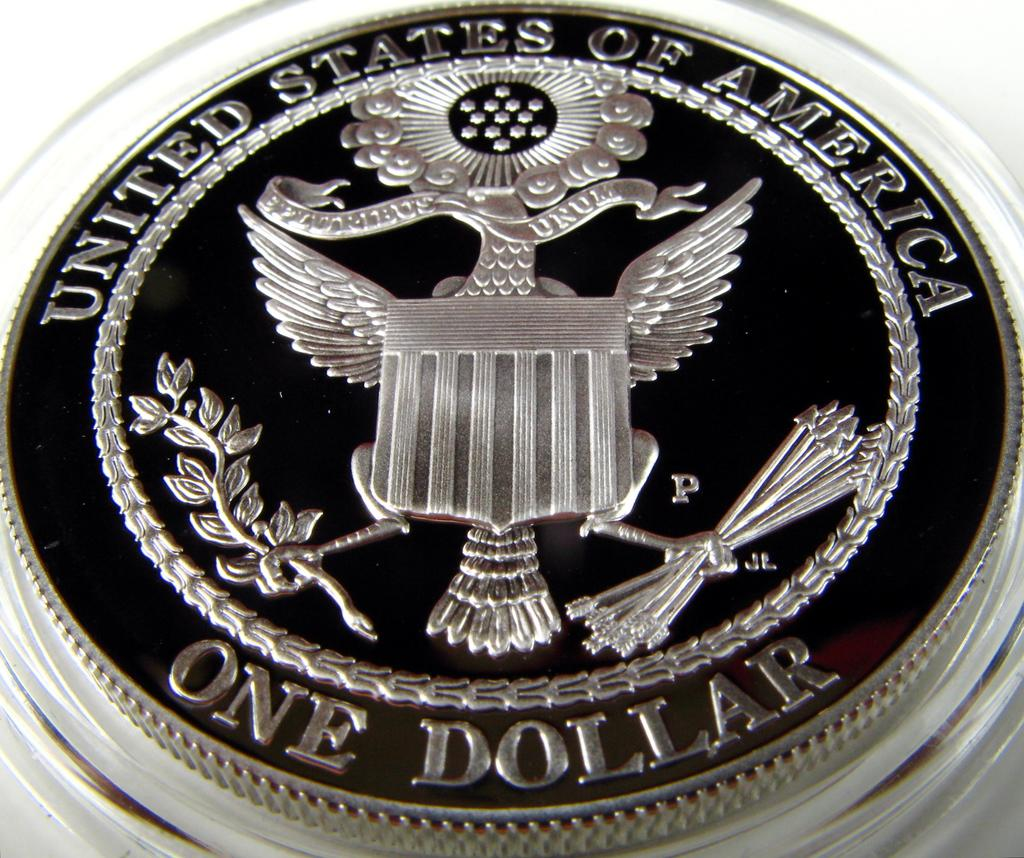<image>
Create a compact narrative representing the image presented. A one dollar united states of america coin 